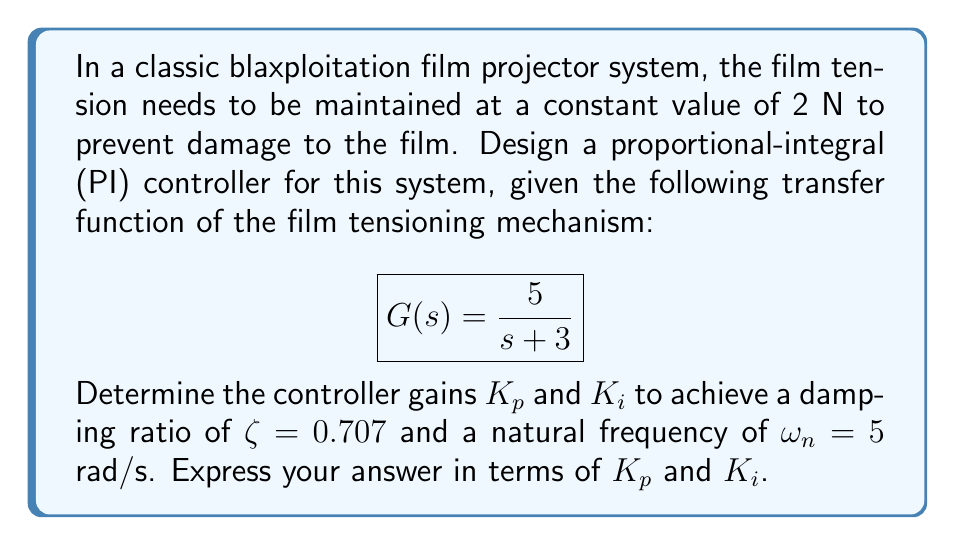Give your solution to this math problem. To design a PI controller for this system, we'll follow these steps:

1) The transfer function of a PI controller is:

   $$C(s) = K_p + \frac{K_i}{s}$$

2) The closed-loop transfer function of the system with the PI controller is:

   $$T(s) = \frac{C(s)G(s)}{1 + C(s)G(s)} = \frac{(K_p s + K_i) \cdot 5}{s^2 + (3+5K_p)s + 5K_i}$$

3) The characteristic equation of this closed-loop system is:

   $$s^2 + (3+5K_p)s + 5K_i = 0$$

4) For a second-order system, the characteristic equation has the form:

   $$s^2 + 2\zeta\omega_n s + \omega_n^2 = 0$$

5) Comparing these equations, we can deduce:

   $$3 + 5K_p = 2\zeta\omega_n$$
   $$5K_i = \omega_n^2$$

6) Substituting the given values $\zeta = 0.707$ and $\omega_n = 5$ rad/s:

   $$3 + 5K_p = 2 \cdot 0.707 \cdot 5 = 7.07$$
   $$5K_i = 5^2 = 25$$

7) Solving these equations:

   $$K_p = \frac{7.07 - 3}{5} = 0.814$$
   $$K_i = \frac{25}{5} = 5$$

Therefore, the PI controller gains should be $K_p = 0.814$ and $K_i = 5$.
Answer: $K_p = 0.814$, $K_i = 5$ 